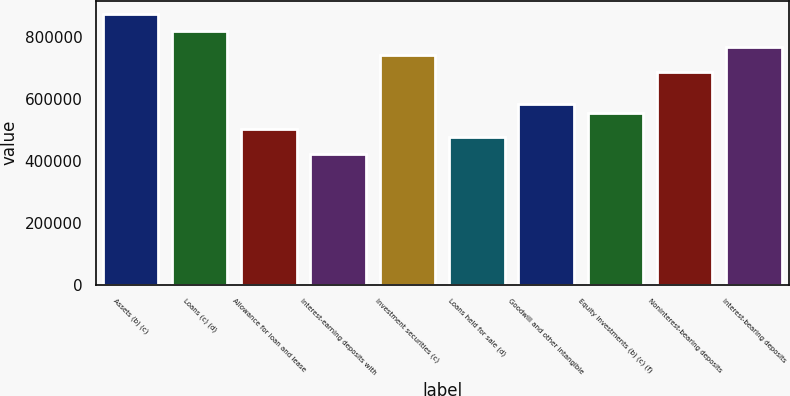<chart> <loc_0><loc_0><loc_500><loc_500><bar_chart><fcel>Assets (b) (c)<fcel>Loans (c) (d)<fcel>Allowance for loan and lease<fcel>Interest-earning deposits with<fcel>Investment securities (c)<fcel>Loans held for sale (d)<fcel>Goodwill and other intangible<fcel>Equity investments (b) (c) (f)<fcel>Noninterest-bearing deposits<fcel>Interest-bearing deposits<nl><fcel>871956<fcel>819110<fcel>502036<fcel>422767<fcel>739842<fcel>475613<fcel>581304<fcel>554882<fcel>686996<fcel>766265<nl></chart> 